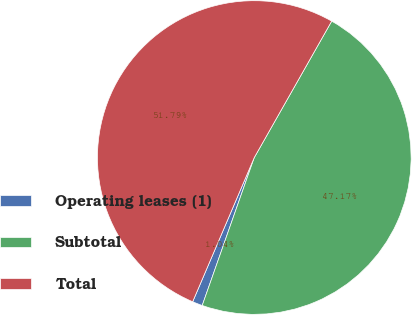Convert chart to OTSL. <chart><loc_0><loc_0><loc_500><loc_500><pie_chart><fcel>Operating leases (1)<fcel>Subtotal<fcel>Total<nl><fcel>1.04%<fcel>47.17%<fcel>51.79%<nl></chart> 